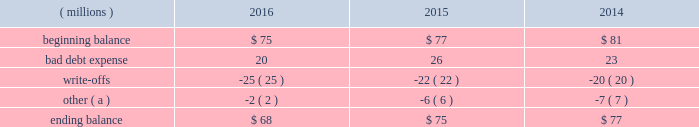Cash and cash equivalents cash equivalents include highly-liquid investments with a maturity of three months or less when purchased .
Accounts receivable and allowance for doubtful accounts accounts receivable are carried at the invoiced amounts , less an allowance for doubtful accounts , and generally do not bear interest .
The company estimates the balance of allowance for doubtful accounts by analyzing accounts receivable balances by age and applying historical write-off and collection trend rates .
The company 2019s estimates include separately providing for customer receivables based on specific circumstances and credit conditions , and when it is deemed probable that the balance is uncollectible .
Account balances are charged off against the allowance when it is determined the receivable will not be recovered .
The company 2019s allowance for doubtful accounts balance also includes an allowance for the expected return of products shipped and credits related to pricing or quantities shipped of $ 14 million , $ 15 million and $ 14 million as of december 31 , 2016 , 2015 , and 2014 , respectively .
Returns and credit activity is recorded directly to sales as a reduction .
The table summarizes the activity in the allowance for doubtful accounts: .
( a ) other amounts are primarily the effects of changes in currency translations and the impact of allowance for returns and credits .
Inventory valuations inventories are valued at the lower of cost or market .
Certain u.s .
Inventory costs are determined on a last-in , first-out ( 201clifo 201d ) basis .
Lifo inventories represented 40% ( 40 % ) and 39% ( 39 % ) of consolidated inventories as of december 31 , 2016 and 2015 , respectively .
Lifo inventories include certain legacy nalco u.s .
Inventory acquired at fair value as part of the nalco merger .
All other inventory costs are determined using either the average cost or first-in , first-out ( 201cfifo 201d ) methods .
Inventory values at fifo , as shown in note 5 , approximate replacement cost .
During 2015 , the company improved and standardized estimates related to its inventory reserves and product costing , resulting in a net pre-tax charge of approximately $ 6 million .
Separately , the actions resulted in a charge of $ 20.6 million related to inventory reserve calculations , partially offset by a gain of $ 14.5 million related to the capitalization of certain cost components into inventory .
During 2016 , the company took additional actions to improve and standardize estimates related to the capitalization of certain cost components into inventory , which resulted in a gain of $ 6.2 million .
These items are reflected within special ( gains ) and charges , as discussed in note 3 .
Property , plant and equipment property , plant and equipment assets are stated at cost .
Merchandising and customer equipment consists principally of various dispensing systems for the company 2019s cleaning and sanitizing products , dishwashing machines and process control and monitoring equipment .
Certain dispensing systems capitalized by the company are accounted for on a mass asset basis , whereby equipment is capitalized and depreciated as a group and written off when fully depreciated .
The company capitalizes both internal and external costs of development or purchase of computer software for internal use .
Costs incurred for data conversion , training and maintenance associated with capitalized software are expensed as incurred .
Expenditures for major renewals and improvements , which significantly extend the useful lives of existing plant and equipment , are capitalized and depreciated .
Expenditures for repairs and maintenance are charged to expense as incurred .
Upon retirement or disposition of plant and equipment , the cost and related accumulated depreciation are removed from the accounts and any resulting gain or loss is recognized in income .
Depreciation is charged to operations using the straight-line method over the assets 2019 estimated useful lives ranging from 5 to 40 years for buildings and leasehold improvements , 3 to 20 years for machinery and equipment , 3 to 15 years for merchandising and customer equipment and 3 to 7 years for capitalized software .
The straight-line method of depreciation reflects an appropriate allocation of the cost of the assets to earnings in proportion to the amount of economic benefits obtained by the company in each reporting period .
Depreciation expense was $ 561 million , $ 560 million and $ 558 million for 2016 , 2015 and 2014 , respectively. .
What is the net change in the balance of allowance for doubtful accounts during 2016? 
Computations: (68 - 75)
Answer: -7.0. 